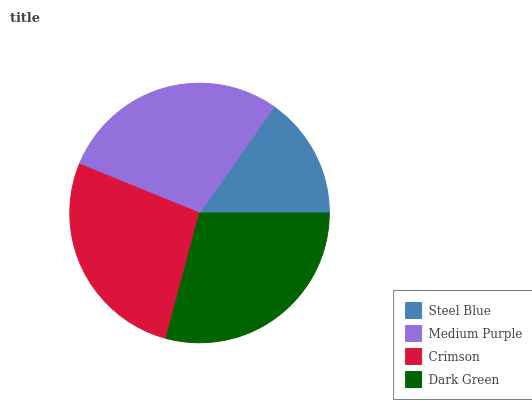Is Steel Blue the minimum?
Answer yes or no. Yes. Is Dark Green the maximum?
Answer yes or no. Yes. Is Medium Purple the minimum?
Answer yes or no. No. Is Medium Purple the maximum?
Answer yes or no. No. Is Medium Purple greater than Steel Blue?
Answer yes or no. Yes. Is Steel Blue less than Medium Purple?
Answer yes or no. Yes. Is Steel Blue greater than Medium Purple?
Answer yes or no. No. Is Medium Purple less than Steel Blue?
Answer yes or no. No. Is Medium Purple the high median?
Answer yes or no. Yes. Is Crimson the low median?
Answer yes or no. Yes. Is Steel Blue the high median?
Answer yes or no. No. Is Steel Blue the low median?
Answer yes or no. No. 